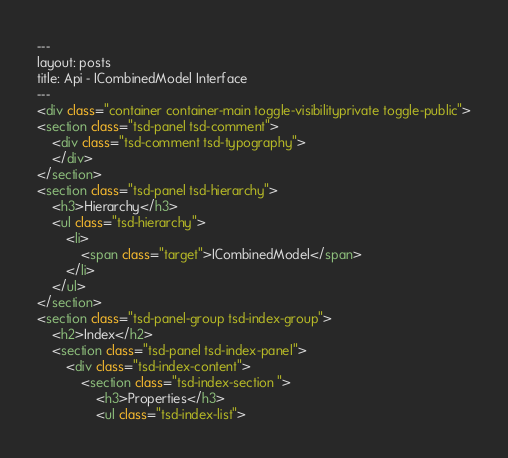Convert code to text. <code><loc_0><loc_0><loc_500><loc_500><_HTML_>---
layout: posts
title: Api - ICombinedModel Interface
---
<div class="container container-main toggle-visibilityprivate toggle-public">
<section class="tsd-panel tsd-comment">
	<div class="tsd-comment tsd-typography">
	</div>
</section>
<section class="tsd-panel tsd-hierarchy">
	<h3>Hierarchy</h3>
	<ul class="tsd-hierarchy">
		<li>
			<span class="target">ICombinedModel</span>
		</li>
	</ul>
</section>
<section class="tsd-panel-group tsd-index-group">
	<h2>Index</h2>
	<section class="tsd-panel tsd-index-panel">
		<div class="tsd-index-content">
			<section class="tsd-index-section ">
				<h3>Properties</h3>
				<ul class="tsd-index-list"></code> 